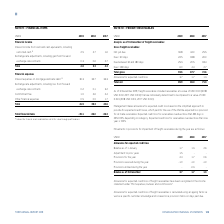According to Torm's financial document, What is recognized in the income statement under Port expenses, bunkers and commissions? Allowance for expected credit loss of freight receivables. The document states: "Allowance for expected credit loss of freight receivables have been recognized in the income statement under "Port expenses, bunkers and commissions"...." Also, How is allowance for expected credit loss of freight receivables calculated? using an ageing factor as well as a specific customer knowledge and is based on a provision matrix on days past due.. The document states: "d credit loss of freight receivables is calculated using an ageing factor as well as a specific customer knowledge and is based on a provision matrix ..." Also, For which years are the movements in provisions for impairment of freight receivables during the year recorded? The document contains multiple relevant values: 2019, 2018, 2017. From the document: "USDm 2019 2018 2017 USDm 2019 2018 2017 USDm 2019 2018 2017..." Additionally, In which year was the Balance as of 1 January the largest? According to the financial document, 2017. The relevant text states: "USDm 2019 2018 2017..." Also, can you calculate: What was the change in the Balance as of 31 December in 2019 from 2018? Based on the calculation: 3.7-1.7, the result is 2 (in millions). This is based on the information: "Balance as of 31 December 3.7 1.7 1.3 Balance as of 31 December 3.7 1.7 1.3..." The key data points involved are: 1.7, 3.7. Also, can you calculate: What was the percentage change in the Balance as of 31 December in 2019 from 2018? To answer this question, I need to perform calculations using the financial data. The calculation is: (3.7-1.7)/1.7, which equals 117.65 (percentage). This is based on the information: "Balance as of 31 December 3.7 1.7 1.3 Balance as of 31 December 3.7 1.7 1.3..." The key data points involved are: 1.7, 3.7. 